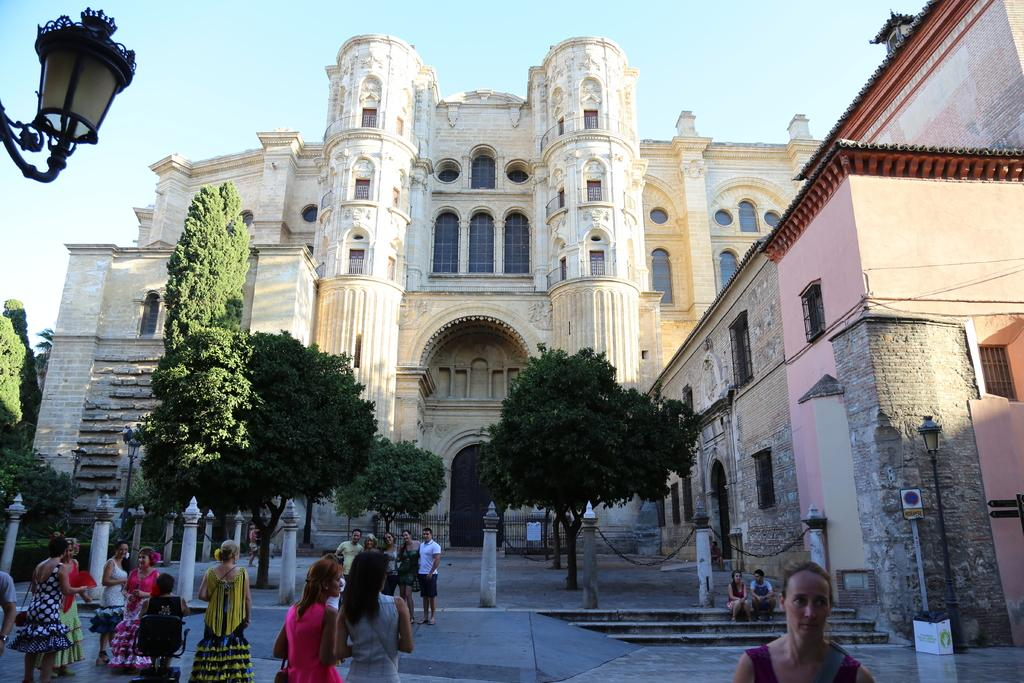Who or what can be seen in the image? There are people and moles in the image. What type of natural environment is depicted in the image? Trees are present in the image, indicating a natural setting. What type of man-made structures are visible in the image? Buildings are visible in the image. What is visible in the background of the image? The sky is in the background of the image. What color is the committee in the image? There is no committee present in the image, so it is not possible to determine its color. 